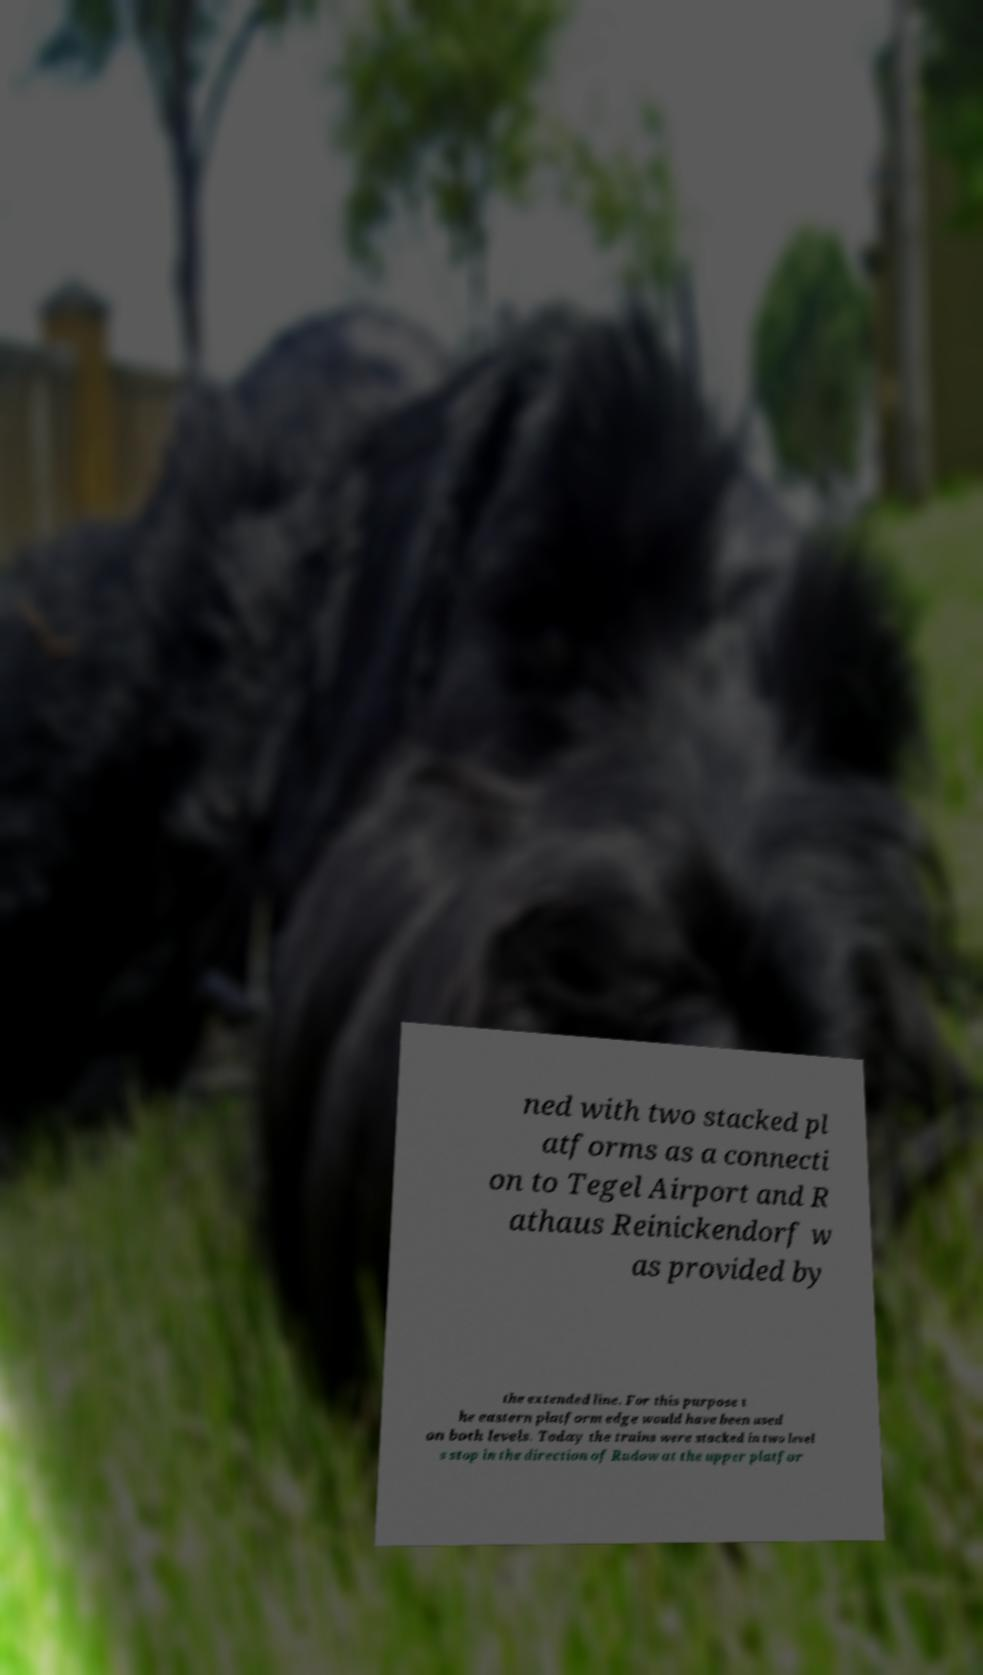There's text embedded in this image that I need extracted. Can you transcribe it verbatim? ned with two stacked pl atforms as a connecti on to Tegel Airport and R athaus Reinickendorf w as provided by the extended line. For this purpose t he eastern platform edge would have been used on both levels. Today the trains were stacked in two level s stop in the direction of Rudow at the upper platfor 